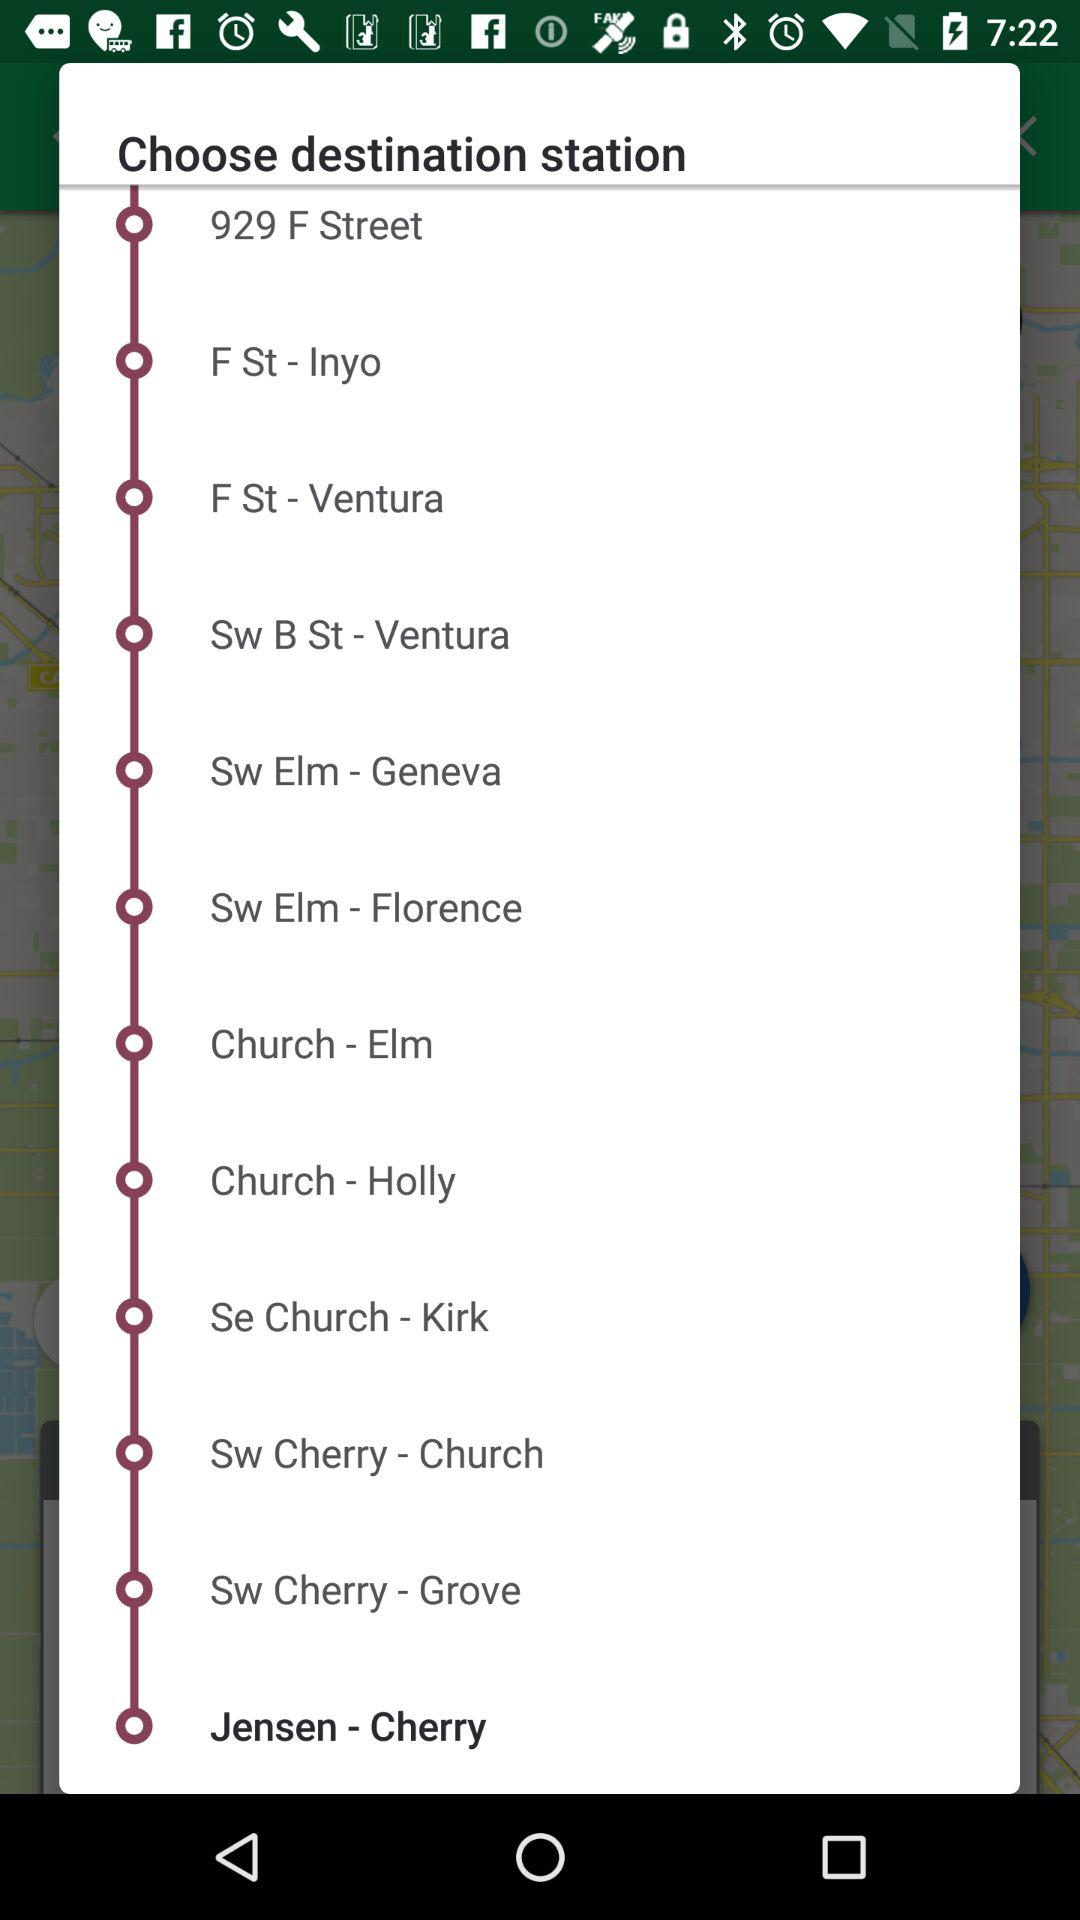What is the selected destination station? The selected destination station is Jensen-Cherry. 